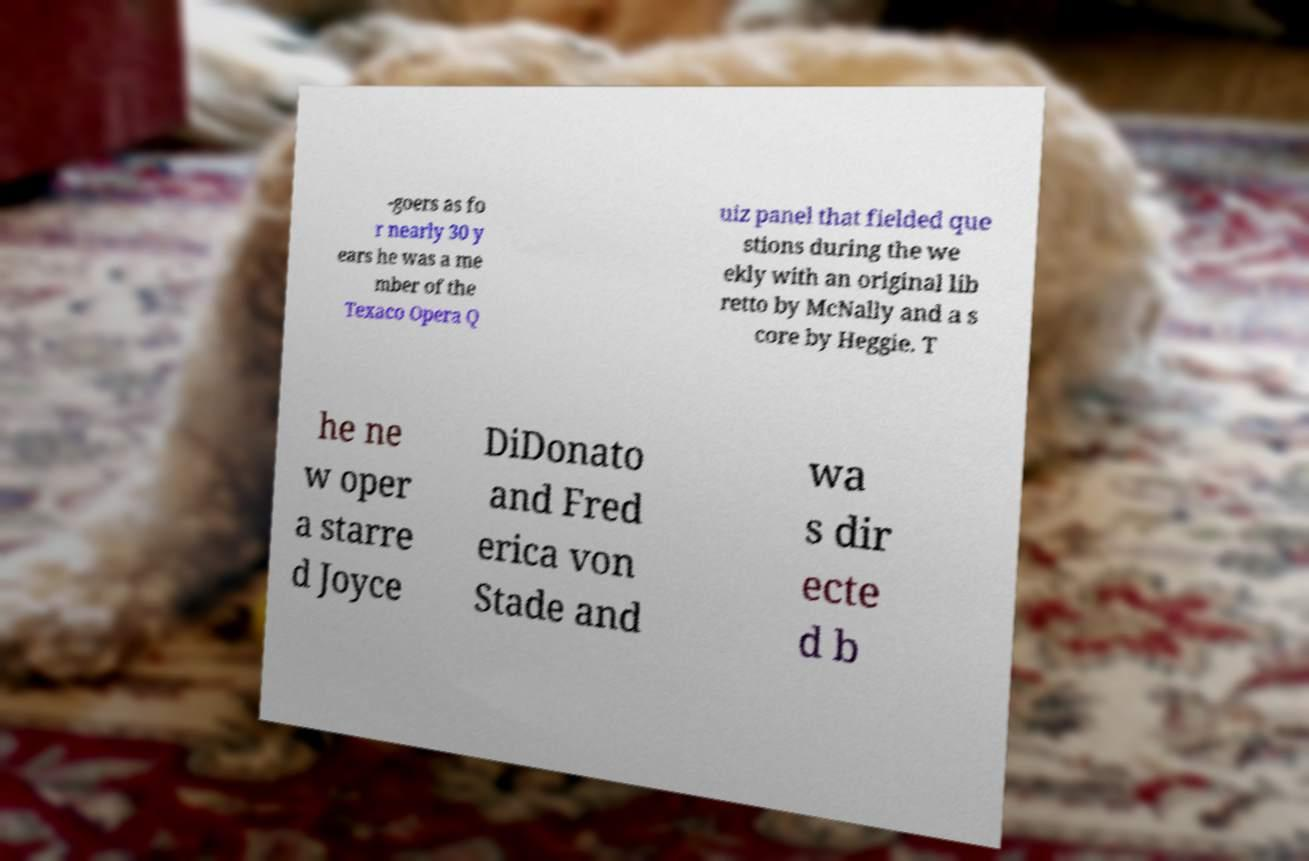Please read and relay the text visible in this image. What does it say? -goers as fo r nearly 30 y ears he was a me mber of the Texaco Opera Q uiz panel that fielded que stions during the we ekly with an original lib retto by McNally and a s core by Heggie. T he ne w oper a starre d Joyce DiDonato and Fred erica von Stade and wa s dir ecte d b 